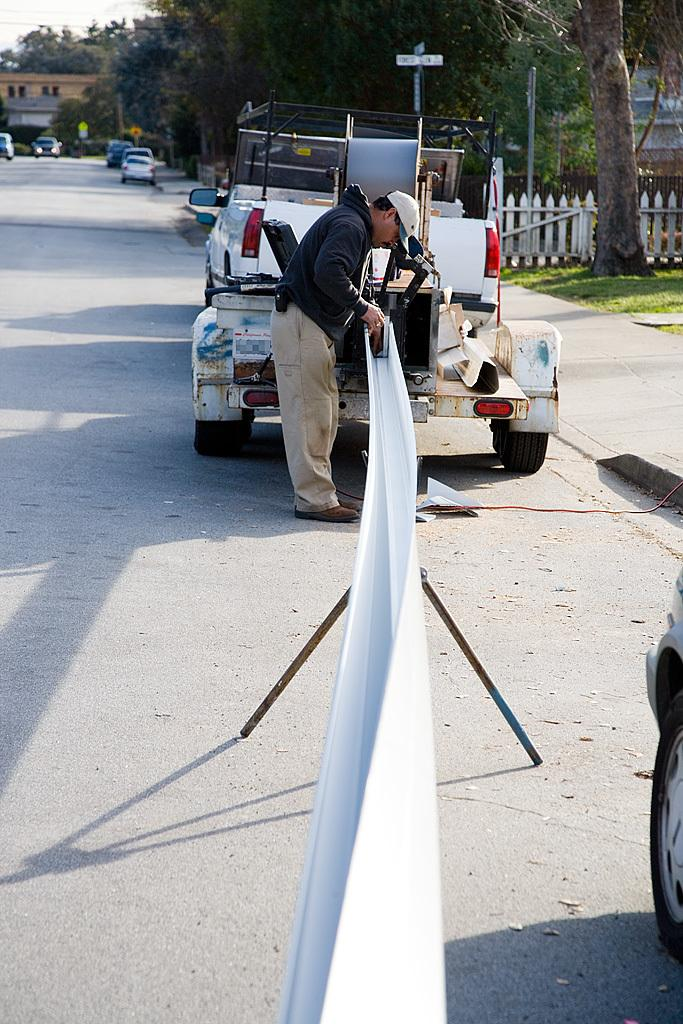What is the person in the image wearing? There is a person wearing a black dress in the image. What else can be seen in the image besides the person? There is a vehicle, a fence, trees, and a building in the background of the image. How many units of time have passed since the fire started in the image? There is no fire present in the image, so it is not possible to determine how many units of time have passed since a fire started. 